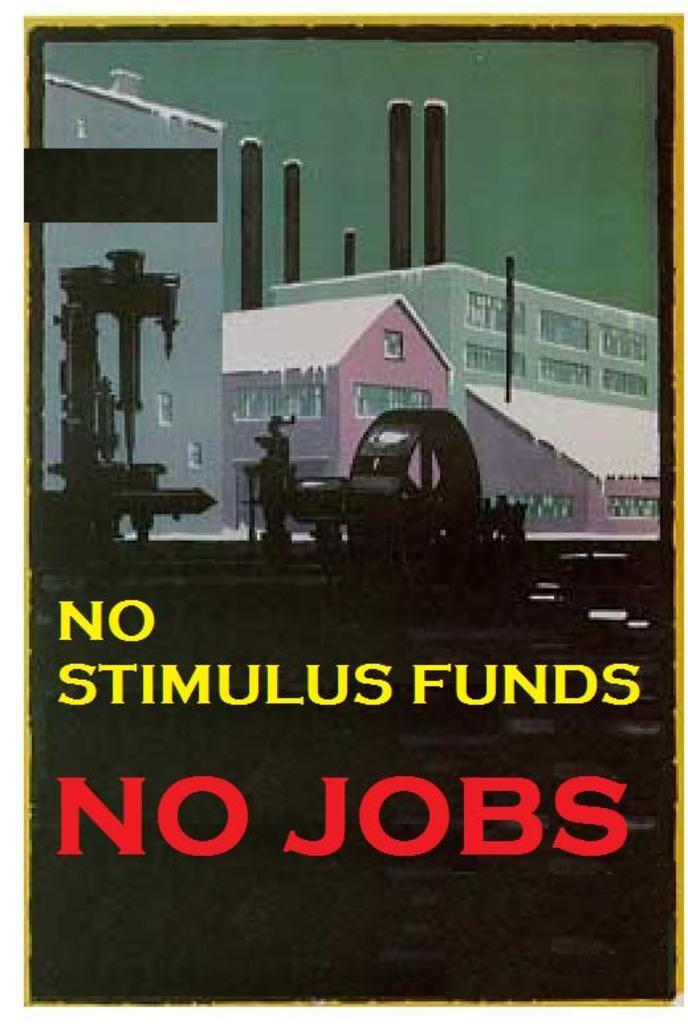What is the main subject of the poster in the image? The poster contains an image of ground with green grass. What can be seen in the background of the image on the poster? There are buildings in the background of the poster. Is there any text on the poster? Yes, there is text at the bottom of the poster. Can you describe the haircut of the person standing next to the sea in the image? There is no person standing next to the sea in the image, nor is there any sea present. 